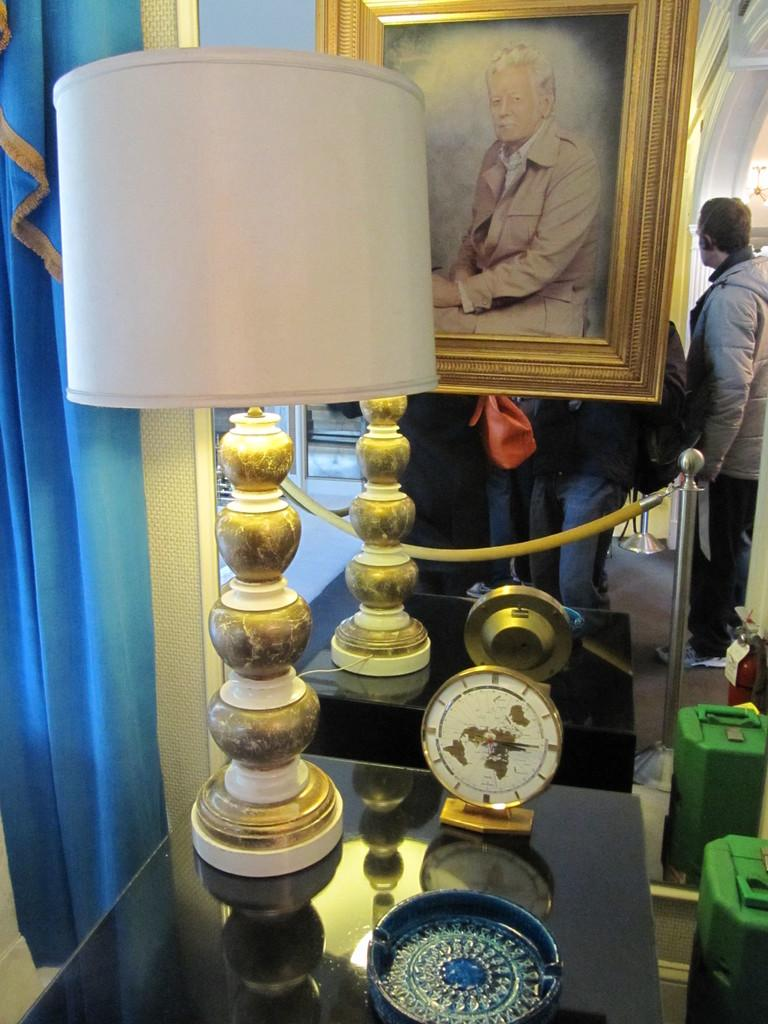What is on the table in the image? There is a lamp on a table in the image. What else can be seen on the table? There are other objects on the table. What is hanging on the wall in the image? There is a photo frame in the image. What color are the curtains on the left side of the image? The curtains on the left side of the image are blue. What type of barrier is visible in the image? There is a rope fence in the image. Can you describe the people in the image? People are standing at the back of the image. How does the earthquake affect the lamp in the image? There is no earthquake present in the image, so it does not affect the lamp. What type of underground storage area can be seen in the image? There is no cellar present in the image. 